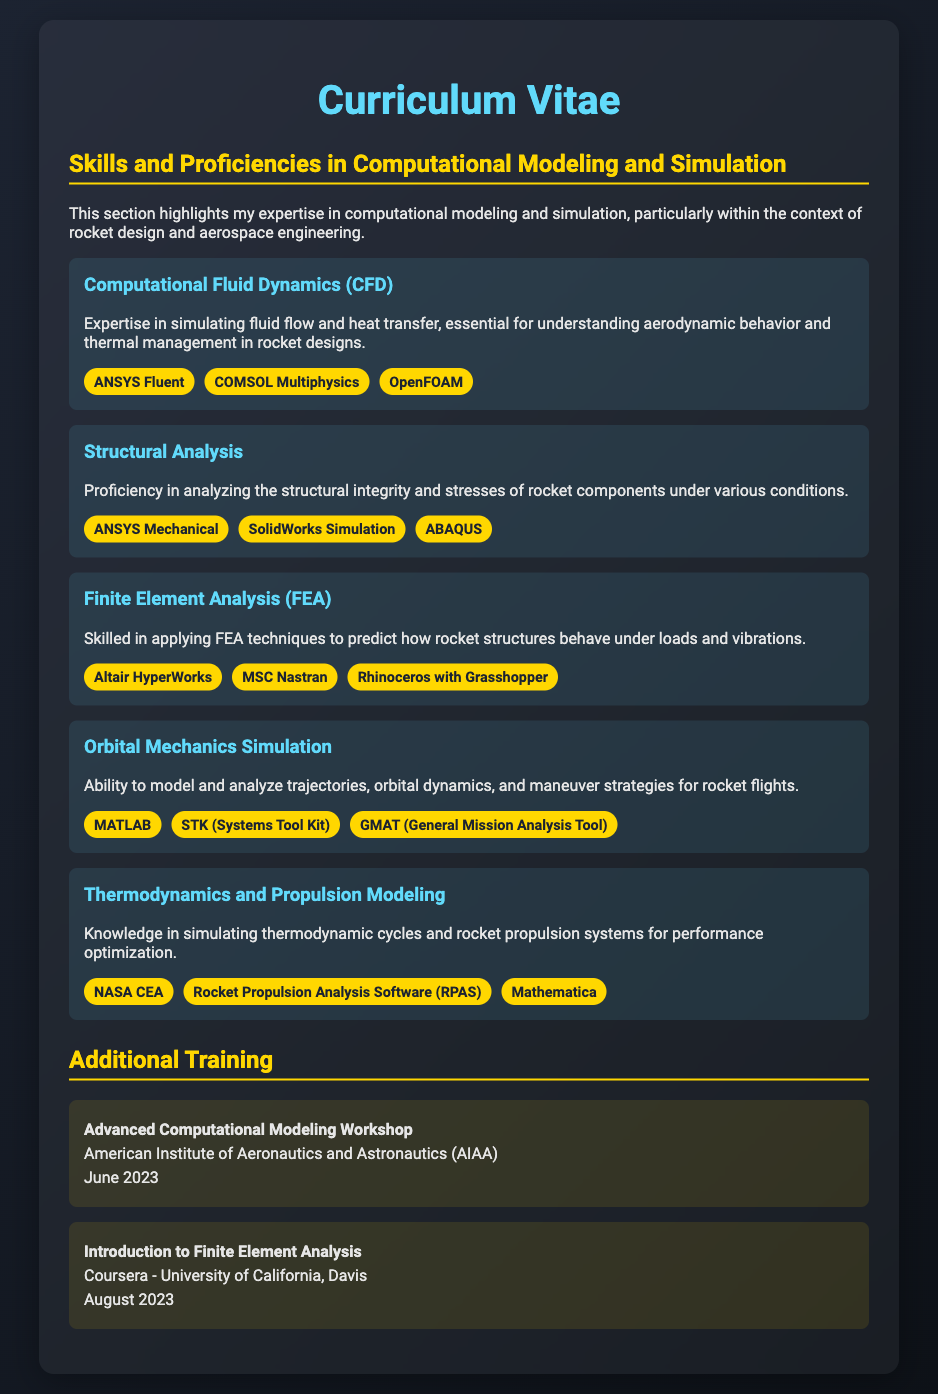what is the title of the CV? The title of the CV is stated at the top of the document as "Curriculum Vitae."
Answer: Curriculum Vitae who is the author of the Computational Modeling and Simulation skills section? The author is implied through the first-person perspective in the document and does not state a specific name.
Answer: Not provided how many software tools are listed under Computational Fluid Dynamics? The document lists three software tools under this section.
Answer: 3 name one software tool used for Structural Analysis. One of the software tools mentioned for Structural Analysis is "ANSYS Mechanical."
Answer: ANSYS Mechanical what is the date of the Advanced Computational Modeling Workshop training? The document specifies that the training took place in June 2023.
Answer: June 2023 which software tool is used for Orbital Mechanics Simulation? The document mentions "MATLAB" as a tool for Orbital Mechanics Simulation.
Answer: MATLAB what type of analysis is associated with ANSYS Mechanical? The document associates ANSYS Mechanical with Structural Analysis.
Answer: Structural Analysis how many skills are outlined in the skills section? The skills section contains five distinct skills.
Answer: 5 who provided the Introduction to Finite Element Analysis training? The training was provided by Coursera - University of California, Davis.
Answer: Coursera - University of California, Davis 